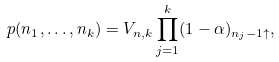<formula> <loc_0><loc_0><loc_500><loc_500>p ( n _ { 1 } , \dots , n _ { k } ) = V _ { n , k } \prod _ { j = 1 } ^ { k } ( 1 - \alpha ) _ { n _ { j } - 1 \uparrow } ,</formula> 